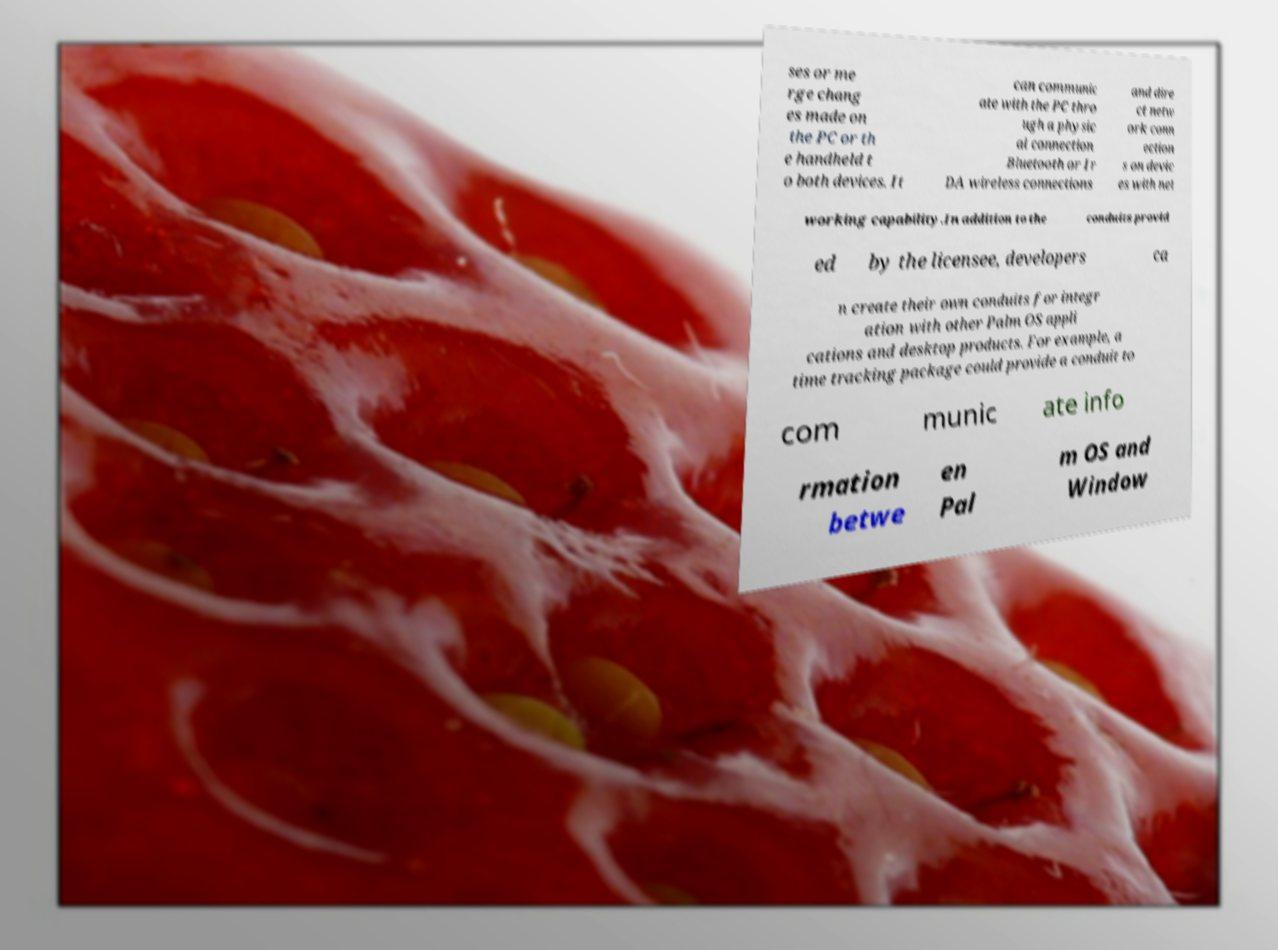There's text embedded in this image that I need extracted. Can you transcribe it verbatim? ses or me rge chang es made on the PC or th e handheld t o both devices. It can communic ate with the PC thro ugh a physic al connection Bluetooth or Ir DA wireless connections and dire ct netw ork conn ection s on devic es with net working capability.In addition to the conduits provid ed by the licensee, developers ca n create their own conduits for integr ation with other Palm OS appli cations and desktop products. For example, a time tracking package could provide a conduit to com munic ate info rmation betwe en Pal m OS and Window 